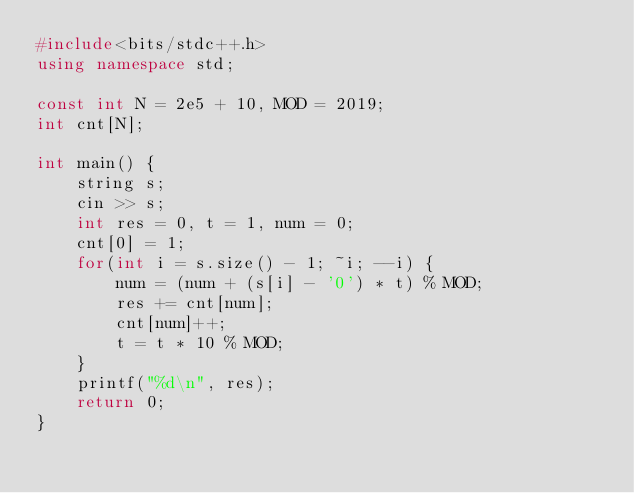<code> <loc_0><loc_0><loc_500><loc_500><_C++_>#include<bits/stdc++.h>
using namespace std;

const int N = 2e5 + 10, MOD = 2019;
int cnt[N];

int main() {
	string s;
	cin >> s;
	int res = 0, t = 1, num = 0;
	cnt[0] = 1;
	for(int i = s.size() - 1; ~i; --i) {
		num = (num + (s[i] - '0') * t) % MOD;
		res += cnt[num];
		cnt[num]++;
		t = t * 10 % MOD;
	}
	printf("%d\n", res);
	return 0;
}</code> 